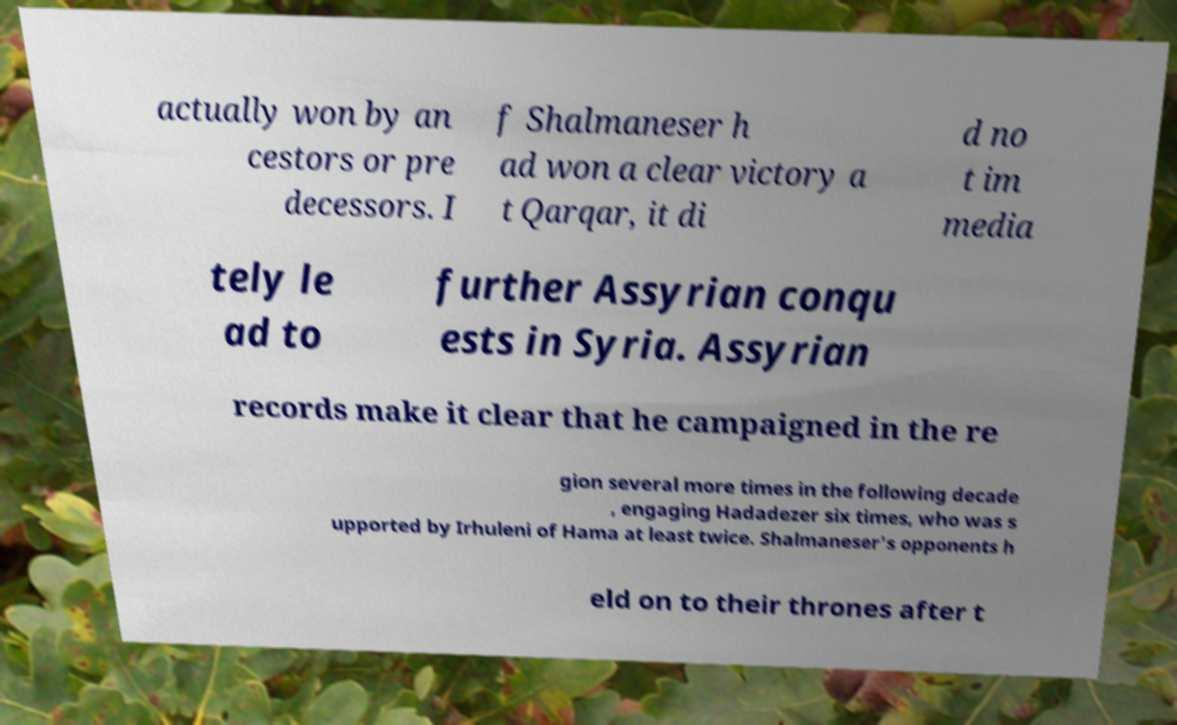What messages or text are displayed in this image? I need them in a readable, typed format. actually won by an cestors or pre decessors. I f Shalmaneser h ad won a clear victory a t Qarqar, it di d no t im media tely le ad to further Assyrian conqu ests in Syria. Assyrian records make it clear that he campaigned in the re gion several more times in the following decade , engaging Hadadezer six times, who was s upported by Irhuleni of Hama at least twice. Shalmaneser's opponents h eld on to their thrones after t 